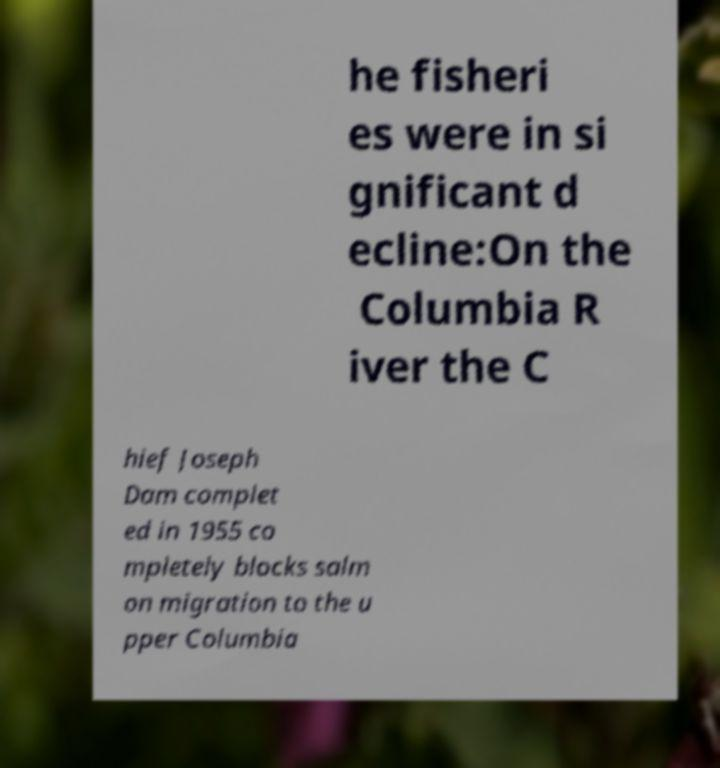I need the written content from this picture converted into text. Can you do that? he fisheri es were in si gnificant d ecline:On the Columbia R iver the C hief Joseph Dam complet ed in 1955 co mpletely blocks salm on migration to the u pper Columbia 